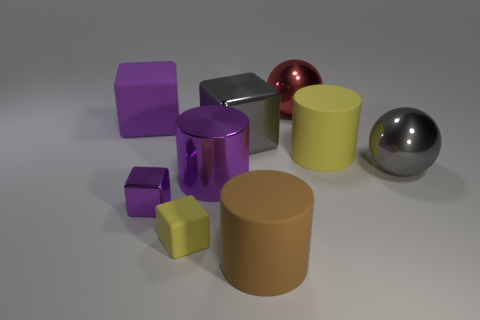Do the big ball in front of the large purple rubber block and the big metallic cube have the same color?
Offer a terse response. Yes. What is the shape of the large object behind the large matte cube to the left of the rubber cylinder that is in front of the tiny shiny object?
Make the answer very short. Sphere. Does the yellow matte cylinder have the same size as the purple block that is behind the metallic cylinder?
Your response must be concise. Yes. Is there a green metallic object that has the same size as the red metal object?
Your answer should be very brief. No. How many other objects are there of the same material as the brown cylinder?
Keep it short and to the point. 3. The object that is behind the gray block and on the right side of the brown rubber thing is what color?
Provide a succinct answer. Red. Do the big gray object to the right of the big red thing and the purple cube behind the large yellow cylinder have the same material?
Offer a terse response. No. Do the yellow thing that is in front of the purple cylinder and the small metallic cube have the same size?
Ensure brevity in your answer.  Yes. There is a shiny cylinder; is it the same color as the big cube on the left side of the small purple shiny object?
Your answer should be compact. Yes. There is a big matte thing that is the same color as the small metal block; what is its shape?
Ensure brevity in your answer.  Cube. 